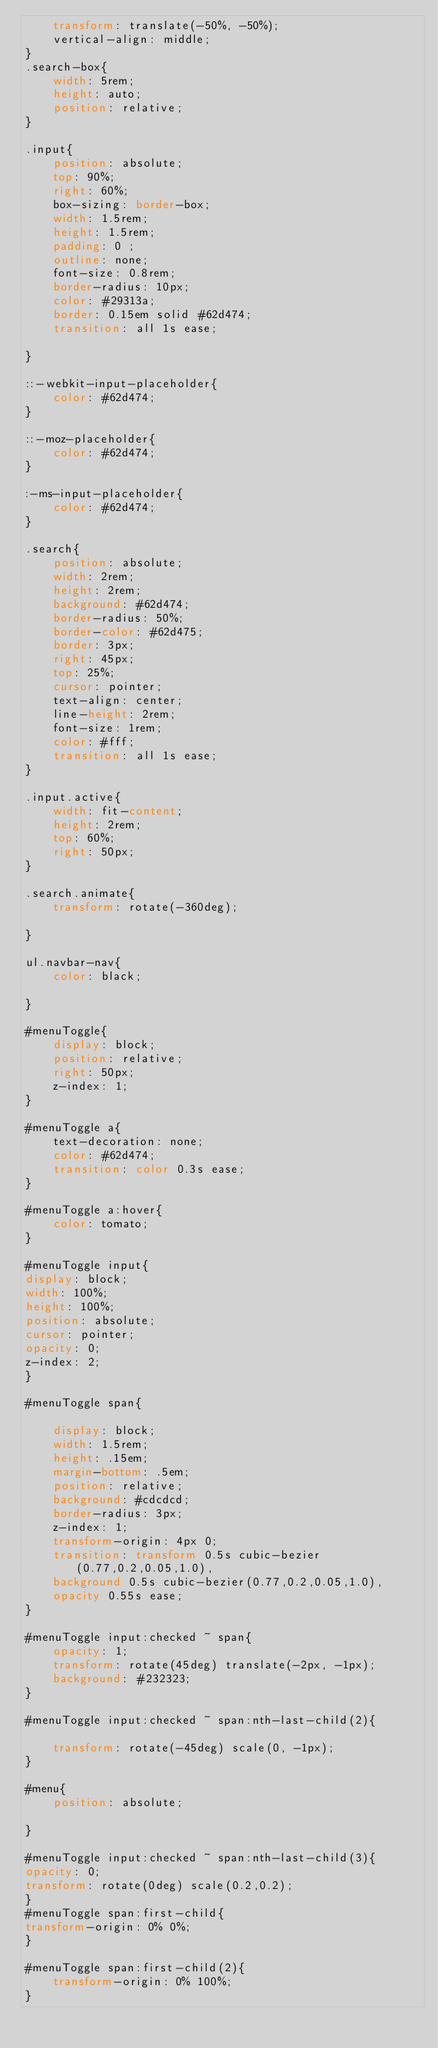Convert code to text. <code><loc_0><loc_0><loc_500><loc_500><_CSS_>    transform: translate(-50%, -50%);
    vertical-align: middle;
}
.search-box{
    width: 5rem;
    height: auto;
    position: relative;
}

.input{
    position: absolute;
    top: 90%;
    right: 60%;
    box-sizing: border-box;
    width: 1.5rem;
    height: 1.5rem;
    padding: 0 ;
    outline: none;
    font-size: 0.8rem;
    border-radius: 10px;
    color: #29313a;
    border: 0.15em solid #62d474;
    transition: all 1s ease;

}

::-webkit-input-placeholder{
    color: #62d474;
}

::-moz-placeholder{
    color: #62d474;
}

:-ms-input-placeholder{
    color: #62d474;
}

.search{
    position: absolute;
    width: 2rem;
    height: 2rem;
    background: #62d474;
    border-radius: 50%;
    border-color: #62d475;
    border: 3px;
    right: 45px;
    top: 25%;
    cursor: pointer;
    text-align: center;
    line-height: 2rem;
    font-size: 1rem;
    color: #fff;
    transition: all 1s ease;
}

.input.active{
    width: fit-content;
    height: 2rem;
    top: 60%;
    right: 50px;
}

.search.animate{
    transform: rotate(-360deg);
    
}

ul.navbar-nav{
    color: black;

}

#menuToggle{
    display: block;
    position: relative;
    right: 50px;
    z-index: 1;
}

#menuToggle a{
    text-decoration: none;
    color: #62d474;
    transition: color 0.3s ease;
}

#menuToggle a:hover{
    color: tomato;
}

#menuToggle input{
display: block;
width: 100%;
height: 100%;
position: absolute;
cursor: pointer;
opacity: 0;
z-index: 2;
}

#menuToggle span{
    
    display: block;
    width: 1.5rem;
    height: .15em;
    margin-bottom: .5em;
    position: relative;
    background: #cdcdcd;
    border-radius: 3px;
    z-index: 1;
    transform-origin: 4px 0;
    transition: transform 0.5s cubic-bezier(0.77,0.2,0.05,1.0),
    background 0.5s cubic-bezier(0.77,0.2,0.05,1.0),
    opacity 0.55s ease;
}

#menuToggle input:checked ~ span{
    opacity: 1;
    transform: rotate(45deg) translate(-2px, -1px);
    background: #232323;
}

#menuToggle input:checked ~ span:nth-last-child(2){
    
    transform: rotate(-45deg) scale(0, -1px);
}

#menu{
    position: absolute;
    
}

#menuToggle input:checked ~ span:nth-last-child(3){
opacity: 0;
transform: rotate(0deg) scale(0.2,0.2);
}
#menuToggle span:first-child{
transform-origin: 0% 0%;
}

#menuToggle span:first-child(2){
    transform-origin: 0% 100%;
}</code> 